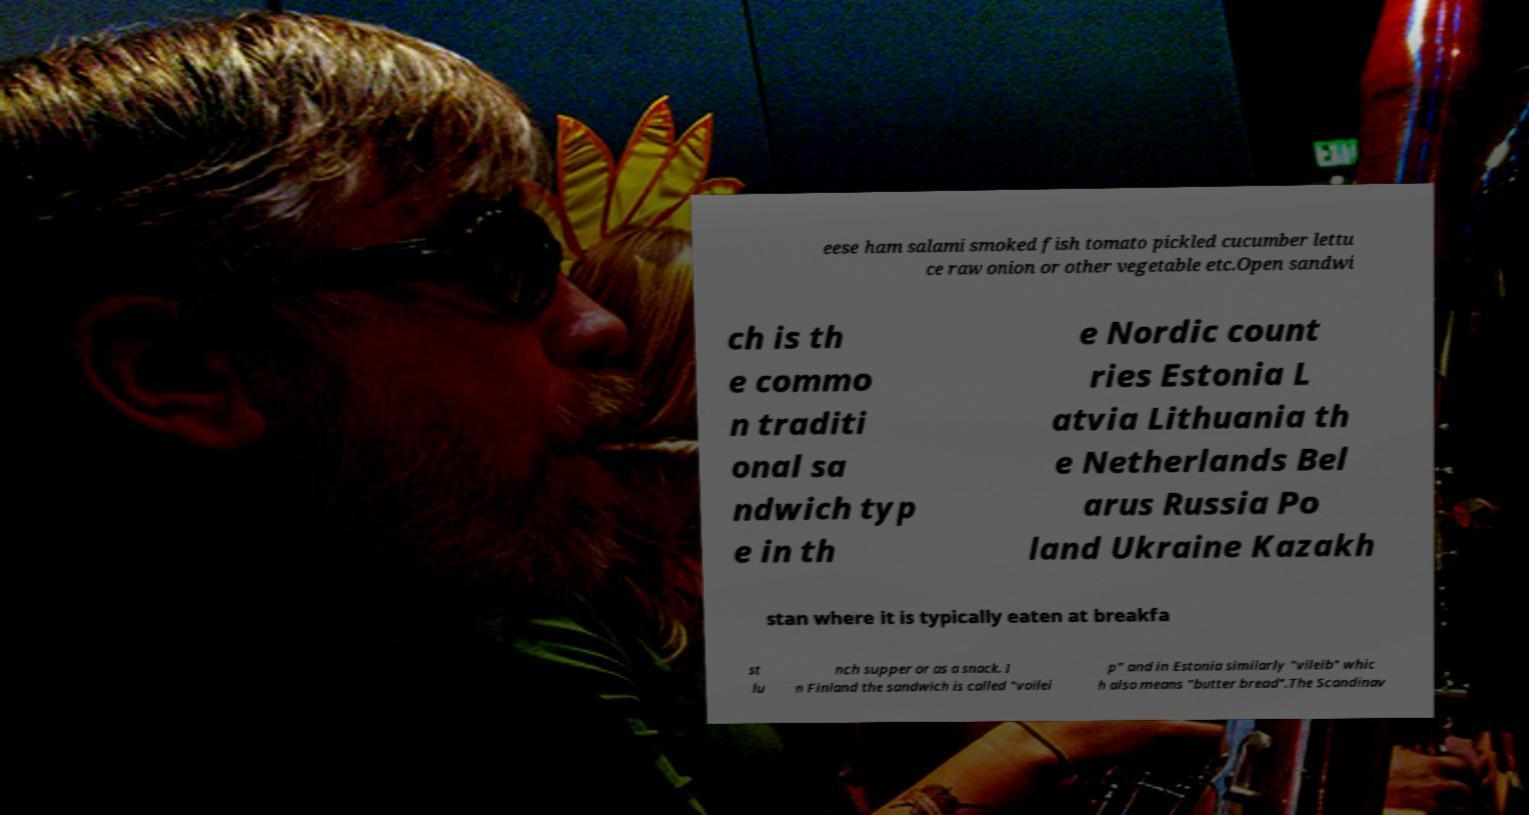What messages or text are displayed in this image? I need them in a readable, typed format. eese ham salami smoked fish tomato pickled cucumber lettu ce raw onion or other vegetable etc.Open sandwi ch is th e commo n traditi onal sa ndwich typ e in th e Nordic count ries Estonia L atvia Lithuania th e Netherlands Bel arus Russia Po land Ukraine Kazakh stan where it is typically eaten at breakfa st lu nch supper or as a snack. I n Finland the sandwich is called "voilei p" and in Estonia similarly "vileib" whic h also means "butter bread".The Scandinav 